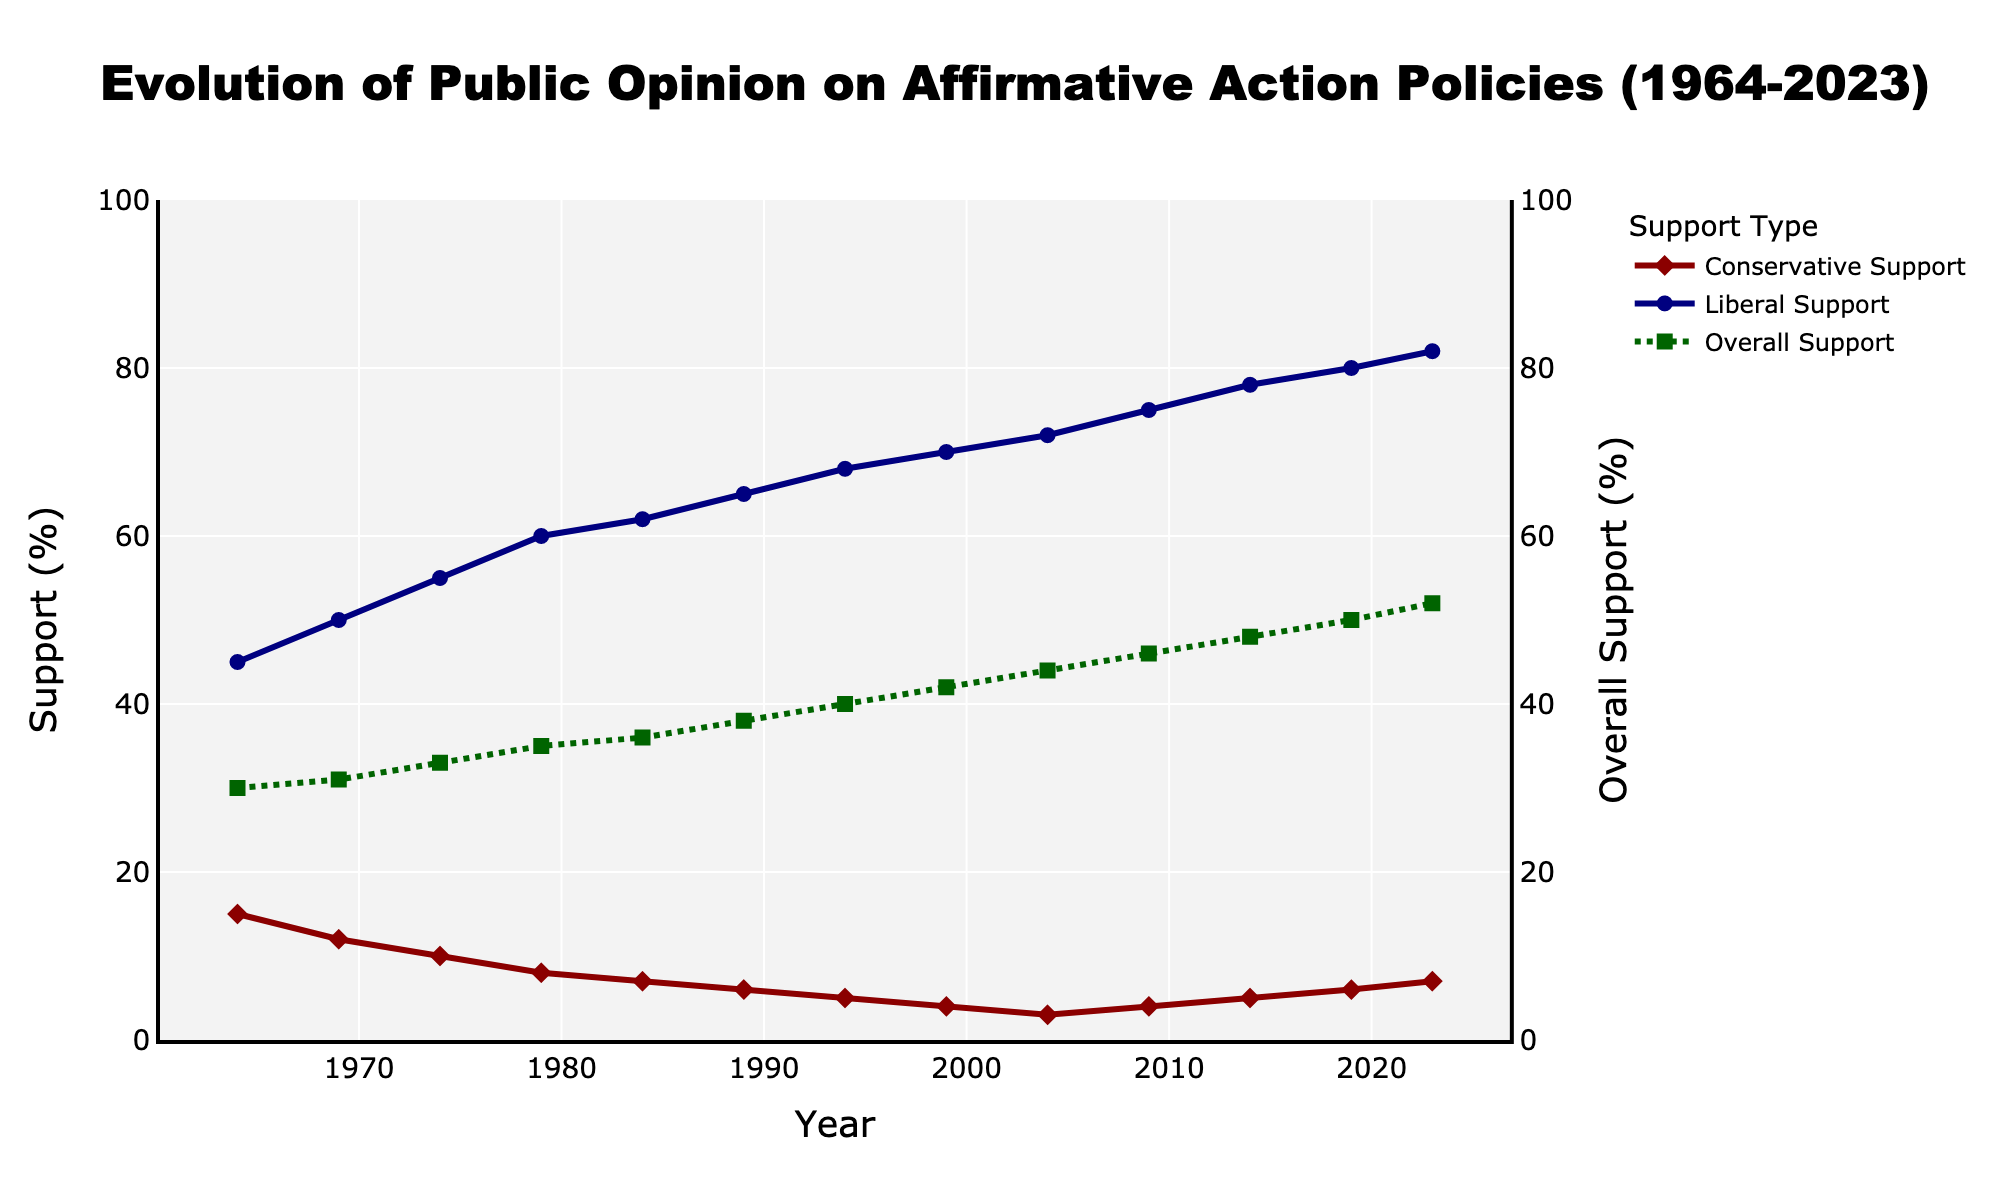What was the overall support for affirmative action policies in 1984? According to the figure, the overall support for affirmative action policies is shown as a green dashed line with square markers. The value in 1984 can be found by locating the year on the x-axis and reading the corresponding value on the y-axis for the green line.
Answer: 36% By how many percentage points did liberal support for affirmative action policies increase from 1964 to 2023? To find the increase, subtract the liberal support value in 1964 from that in 2023. The liberal support in 1964 was 45%, and in 2023, it was 82%. Therefore, the increase is 82% - 45%.
Answer: 37% In what year did conservative support for affirmative action policies reach its lowest point, and what was the percentage? By examining the dark red line representing conservative support, we identify the lowest point. The lowest value on the y-axis corresponds to 3% in 2004.
Answer: 2004, 3% Compare overall support and conservative support percentages in 2004. Which one was higher and by how much? Locate the data points for overall support (green line) and conservative support (dark red line) in 2004. The overall support was 44%, while conservative support was 3%. The difference is 44% - 3%.
Answer: Overall support, by 41 percentage points What is the average liberal support for affirmative action policies from 1964 to 2023? Sum the liberal support values for each time point and divide by the number of years recorded. Adding the values: 45 + 50 + 55 + 60 + 62 + 65 + 68 + 70 + 72 + 75 + 78 + 80 + 82 = 862. There are 13 data points, so the average is 862 / 13.
Answer: 66.3% Which of the three support types had the smallest percentage point change between 2009 and 2023? Calculate the changes for each type from 2009 to 2023:
- Conservative: 7% - 4% = 3%
- Liberal: 82% - 75% = 7%
- Overall: 52% - 46% = 6%
The conservative support had the smallest change of 3 percentage points.
Answer: Conservative support From 1964 to 2019, how did the trends for conservative support and liberal support differ visually? The figure shows that the conservative support (dark red line with diamonds) continually declined from 15% to 6%, while the liberal support (navy line with circles) consistently increased from 45% to 80% over the same period, depicting opposing trends visually.
Answer: Conservative support decreased, liberal support increased How does the conservative support percentage in 1969 compare to the overall support percentage in the same year? Find the values for both conservative (dark red line) and overall support (green dashed line with squares) for 1969. Conservative support was 12%, and overall support was 31%.
Answer: It was 19 percentage points lower In which year did overall support first reach or exceed 50%? Look for the year at which the green dashed line (overall support) first touches or surpasses the 50% mark on the y-axis. This occurred in 2019.
Answer: 2019 